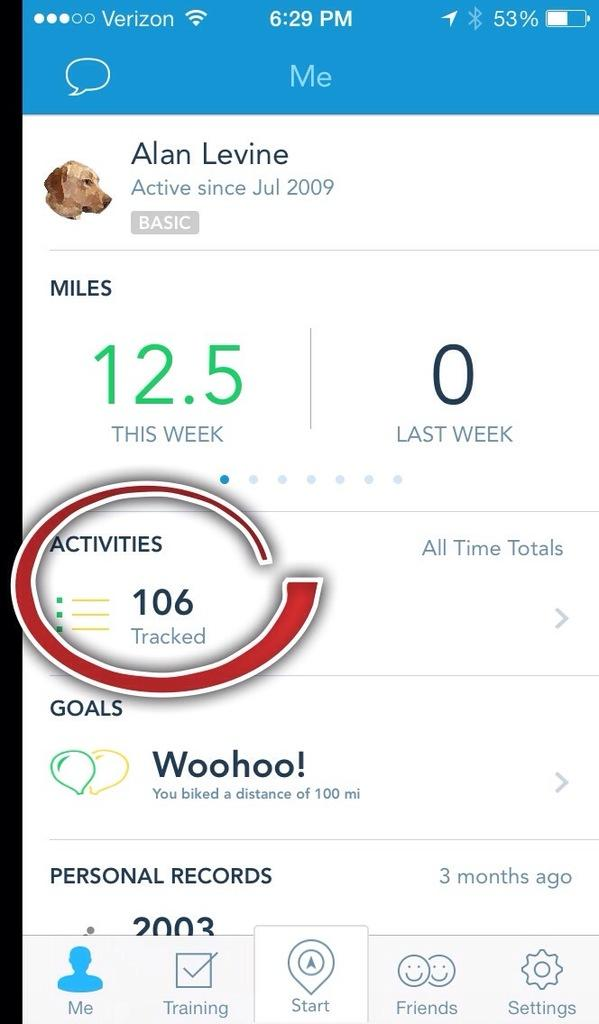<image>
Summarize the visual content of the image. A screenshot of a Verizon phone showing a person's activity tracker. 